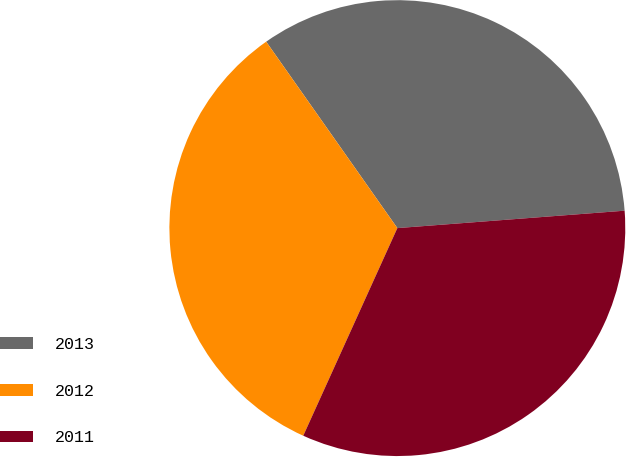Convert chart. <chart><loc_0><loc_0><loc_500><loc_500><pie_chart><fcel>2013<fcel>2012<fcel>2011<nl><fcel>33.54%<fcel>33.47%<fcel>32.99%<nl></chart> 